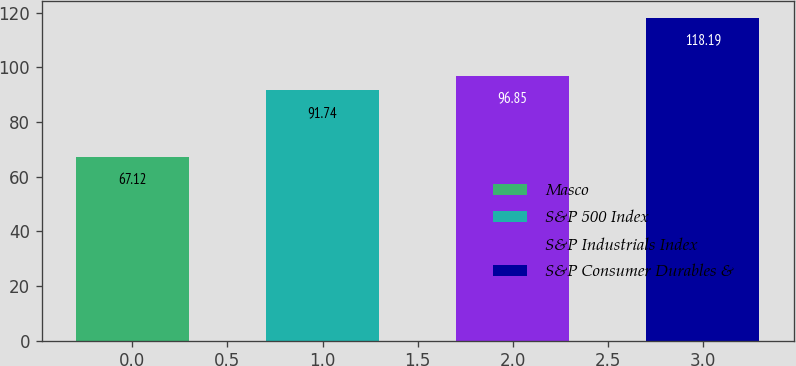<chart> <loc_0><loc_0><loc_500><loc_500><bar_chart><fcel>Masco<fcel>S&P 500 Index<fcel>S&P Industrials Index<fcel>S&P Consumer Durables &<nl><fcel>67.12<fcel>91.74<fcel>96.85<fcel>118.19<nl></chart> 